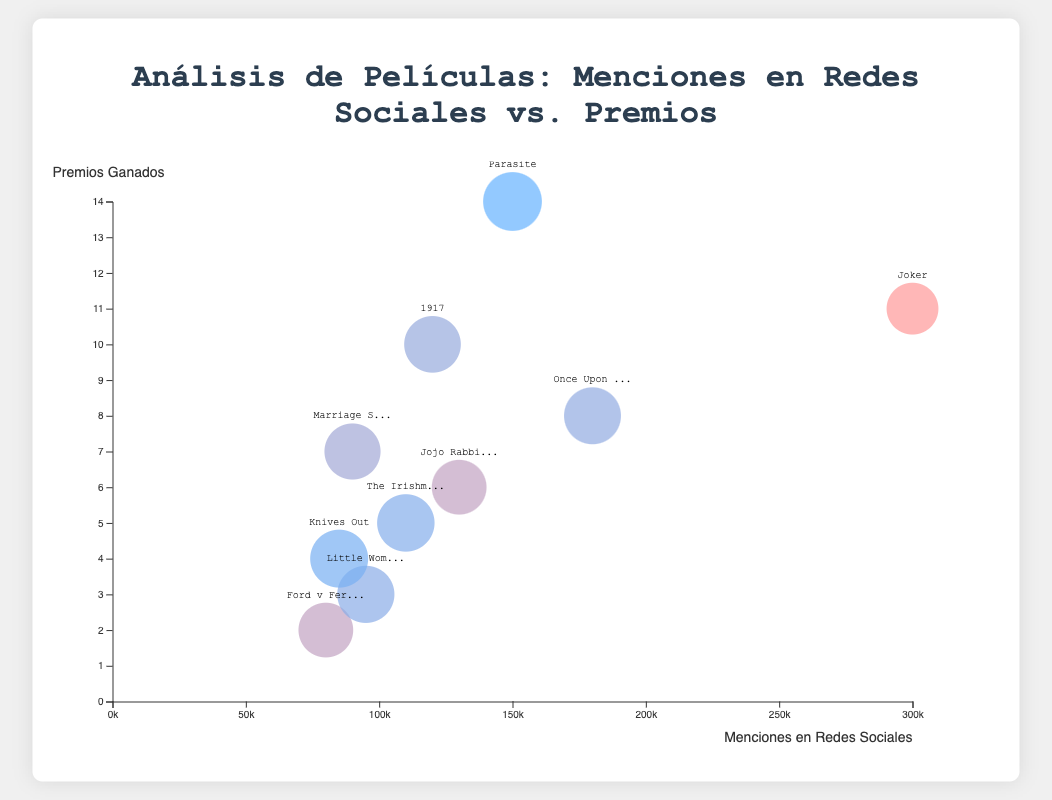¿Cuántas películas tienen más de 100,000 menciones en redes sociales? Observando la gráfica, contamos las burbujas con coordenadas x (menciones en redes sociales) mayores a 100,000. Vemos que "Joker", "Parasite", "1917", "Once Upon a Time in Hollywood", "The Irishman" y "Jojo Rabbit" cumplen esta condición.
Answer: 6 ¿Cuál es la película con más premios ganados? Miramos la altura de las burbujas (coordenada y), la burbuja más alta representa a "Parasite" con 14 premios.
Answer: Parasite ¿Qué película tiene el mayor sentimiento crítico y cuántos premios ha ganado? Observamos las burbujas con el color más cercano al azul oscuro (representa mayor sentimiento crítico). "Parasite" tiene el mayor sentimiento crítico (95%) y ha ganado 14 premios.
Answer: Parasite, 14 ¿Cuál es la diferencia en número de menciones en redes sociales entre "Joker" y "Once Upon a Time in Hollywood"? Localizamos las burbujas de "Joker" y "Once Upon a Time in Hollywood" en el eje x. "Joker" tiene 300,000 menciones y "Once Upon a Time in Hollywood" 180,000. La diferencia es 300,000 - 180,000.
Answer: 120,000 Comparando "Ford v Ferrari" y "Jojo Rabbit", ¿cuál tiene más premios ganados y en cuánto? "Ford v Ferrari" tiene 2 premios y "Jojo Rabbit" tiene 6 premios. La diferencia es 6 - 2.
Answer: Jojo Rabbit, 4 ¿Cuál es la relación entre menciones en redes sociales y premios ganados? Generalizando la distribución de las burbujas, parece que hay una relación aumentada entre menciones en redes sociales y premios ganados. Sin embargo, no es totalmente lineal ya que hay películas con menos premios pero muchas menciones y viceversa.
Answer: Relación moderada ¿Qué película, con más de 10 premios ganados, tiene el menor sentimiento crítico? Filtramos las películas con más de 10 premios: "Parasite" y "Joker". "Joker" tiene el menor sentimiento crítico (70%).
Answer: Joker ¿Cuál es el tamaño de la burbuja que representa "Knives Out", y cómo se relaciona con el sentimiento crítico? Miramos la burbuja con el texto "Knives Out". Su radio indica un sentimiento crítico medio-alto (92%).
Answer: Sentimiento crítico alto ¿Cuál es la diferencia entre el sentimiento crítico de "Marriage Story" y "The Irishman"? "Marriage Story" tiene un sentimiento crítico del 85% y "The Irishman" del 90%. La diferencia es 90 - 85.
Answer: 5 